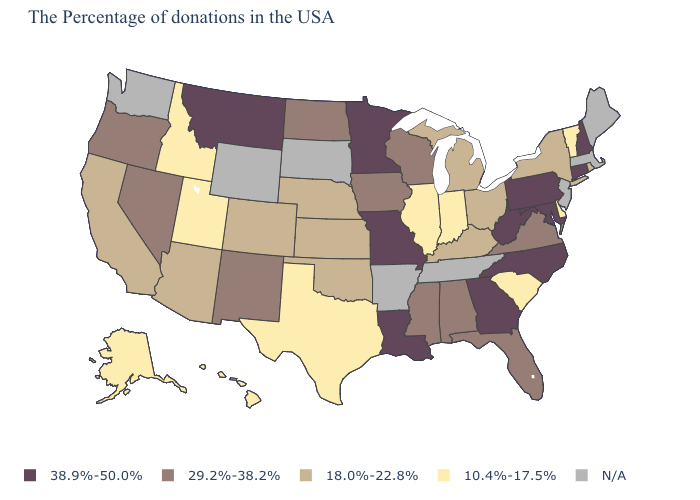Among the states that border Arkansas , which have the lowest value?
Give a very brief answer. Texas. Does the map have missing data?
Concise answer only. Yes. Which states hav the highest value in the West?
Keep it brief. Montana. How many symbols are there in the legend?
Short answer required. 5. Among the states that border New York , which have the highest value?
Give a very brief answer. Connecticut, Pennsylvania. What is the highest value in the MidWest ?
Give a very brief answer. 38.9%-50.0%. Name the states that have a value in the range 29.2%-38.2%?
Concise answer only. Virginia, Florida, Alabama, Wisconsin, Mississippi, Iowa, North Dakota, New Mexico, Nevada, Oregon. Name the states that have a value in the range 38.9%-50.0%?
Short answer required. New Hampshire, Connecticut, Maryland, Pennsylvania, North Carolina, West Virginia, Georgia, Louisiana, Missouri, Minnesota, Montana. Among the states that border New Jersey , does Delaware have the lowest value?
Keep it brief. Yes. Name the states that have a value in the range 38.9%-50.0%?
Write a very short answer. New Hampshire, Connecticut, Maryland, Pennsylvania, North Carolina, West Virginia, Georgia, Louisiana, Missouri, Minnesota, Montana. What is the value of Minnesota?
Quick response, please. 38.9%-50.0%. What is the value of Kansas?
Write a very short answer. 18.0%-22.8%. What is the value of New Jersey?
Keep it brief. N/A. What is the value of Missouri?
Answer briefly. 38.9%-50.0%. Which states have the lowest value in the USA?
Answer briefly. Vermont, Delaware, South Carolina, Indiana, Illinois, Texas, Utah, Idaho, Alaska, Hawaii. 